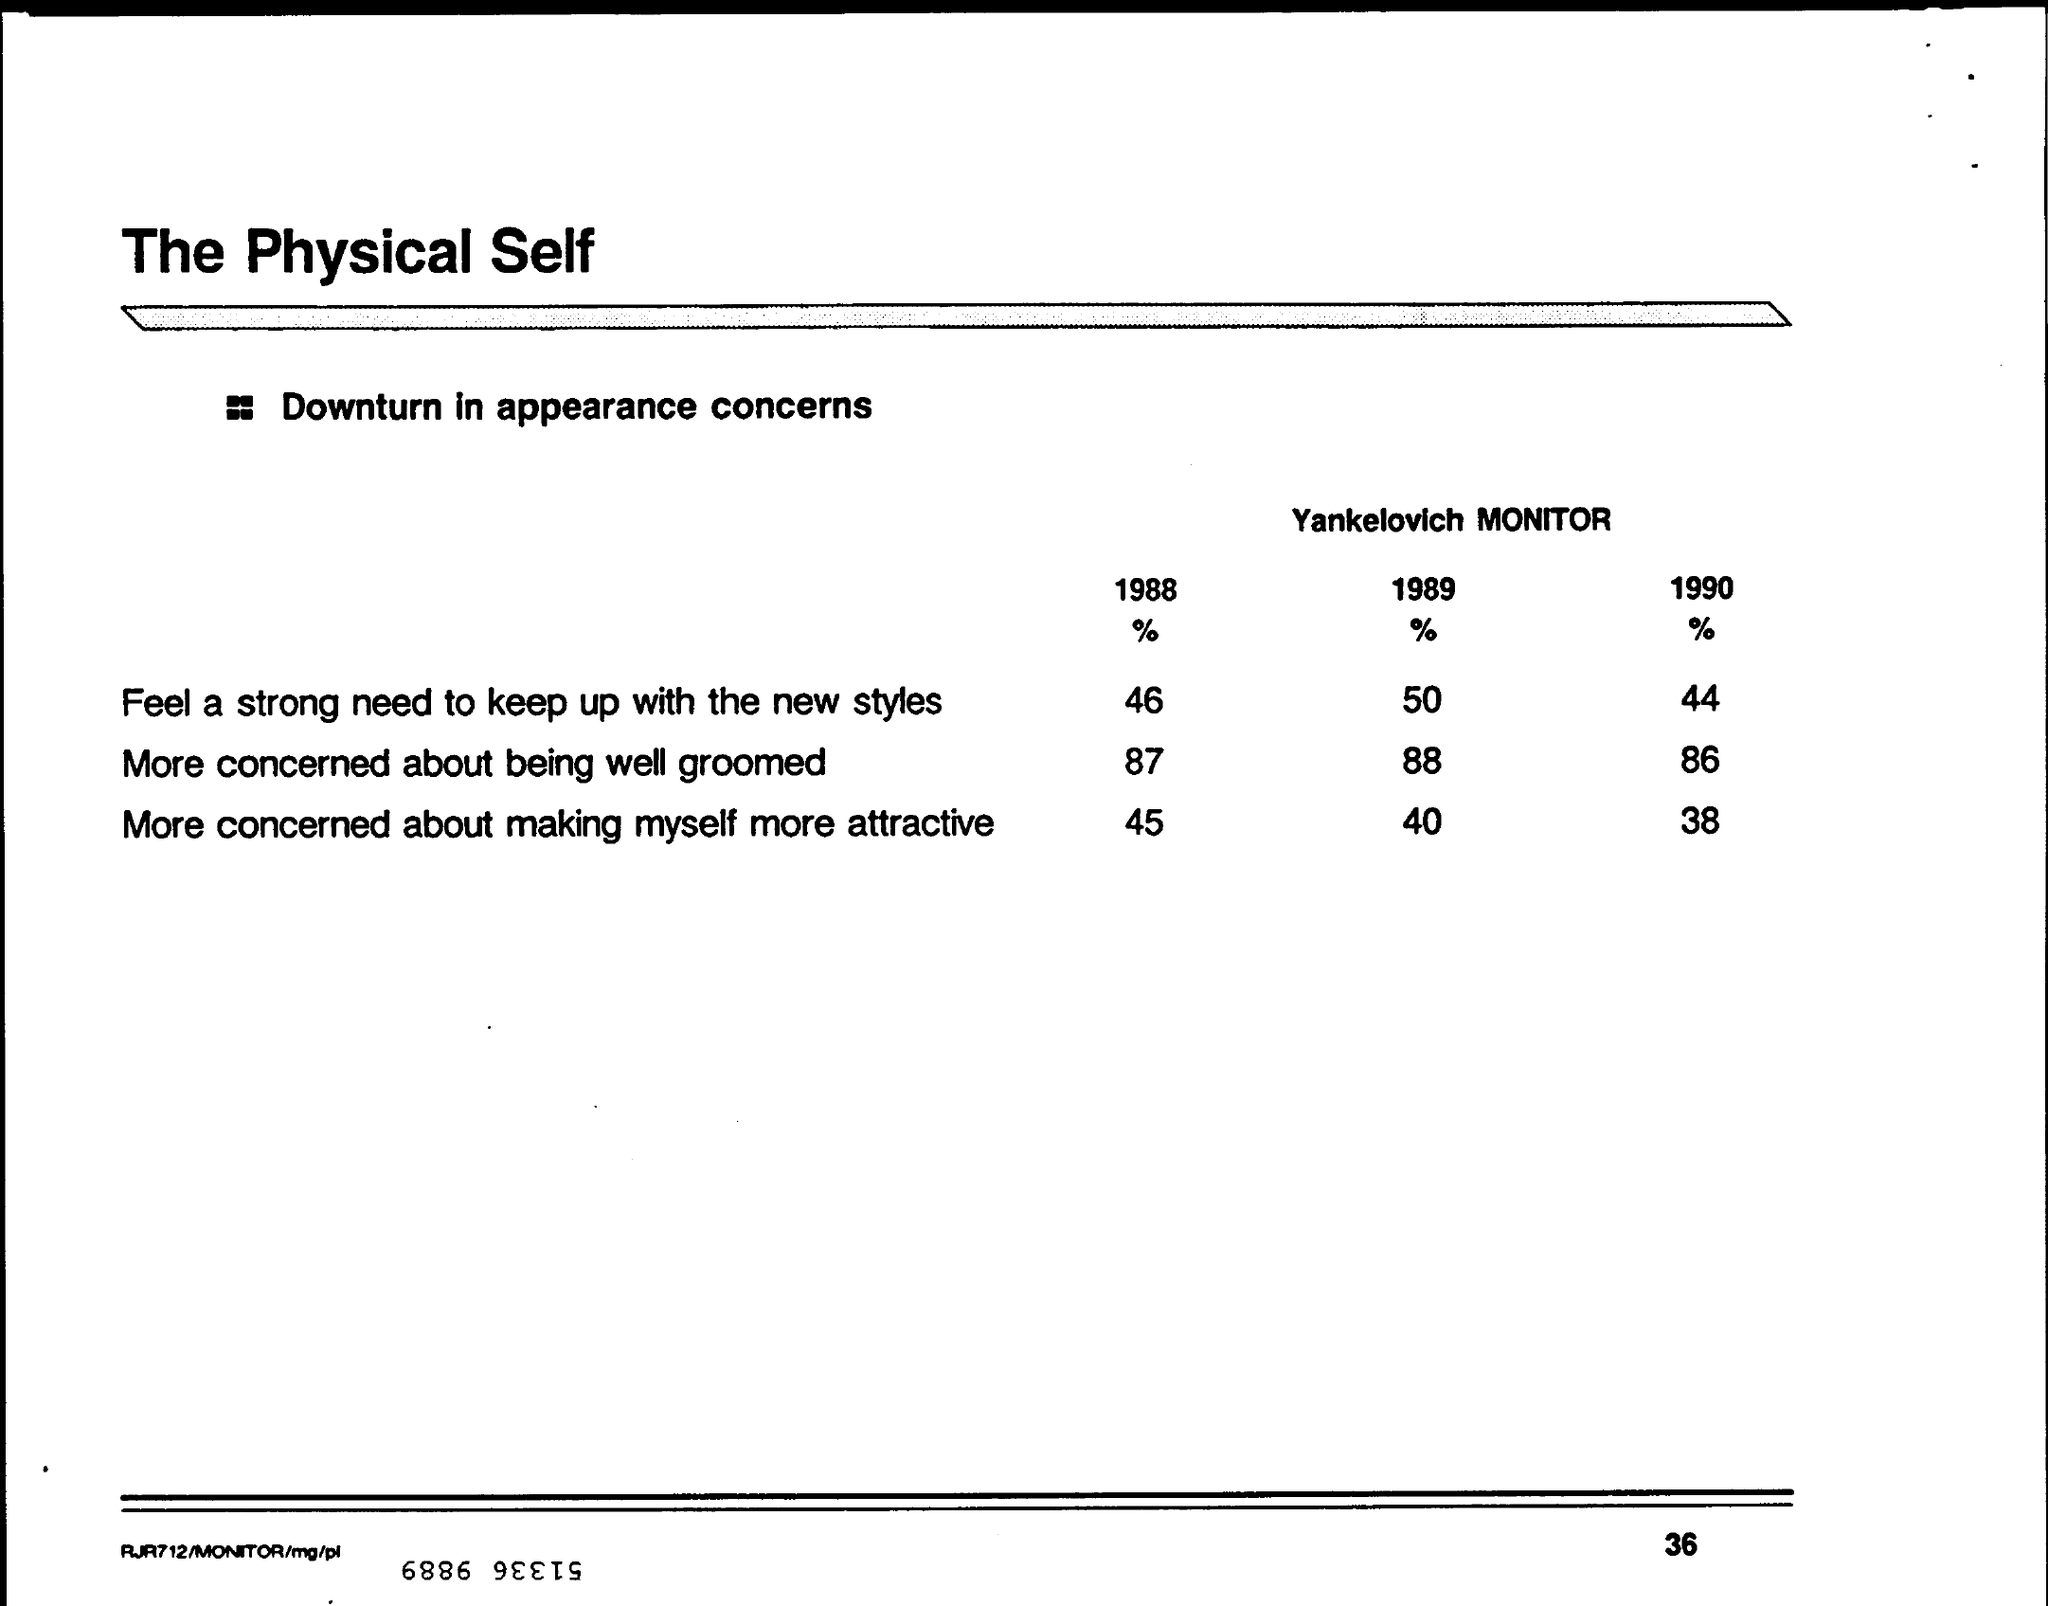What is the % of feel a strong need to keep up with the new styles in the year 1989 ?
Ensure brevity in your answer.  50%. What i sthe % of more concerned about being well groomed in the year 1988 ?
Your response must be concise. 87%. What i sthe % of more concerned about making myself more attractive in the year 1990 ?
Make the answer very short. 38 %. What is the name of the monitor which counts the downturn in appearance concerns ?
Ensure brevity in your answer.  Yankelovich monitor. What is the % of more concerned about being well groomed in the year 1990
Your response must be concise. 86%. What is the % of people feel a strong need to keep up with the new styles in the year 1988 ?
Provide a short and direct response. 46%. 